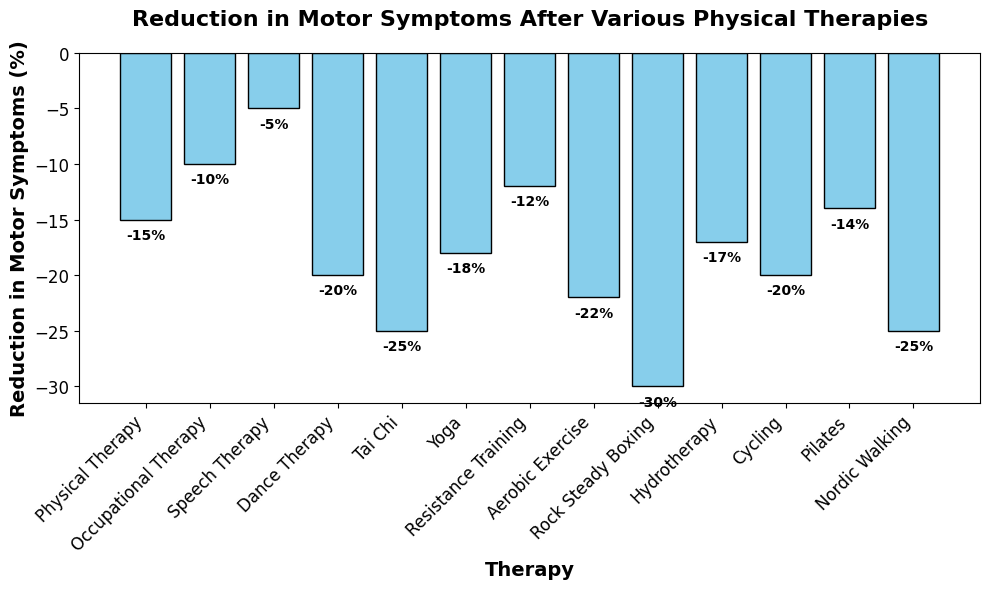Which therapy shows the greatest reduction in motor symptoms? By looking at the heights of the bars, the tallest negative value indicates the greatest reduction. Rock Steady Boxing has the tallest bar, representing the highest reduction of 30%.
Answer: Rock Steady Boxing Which therapies have a reduction of motor symptoms equal to or greater than 20%? Identify bars with heights at -20% or more negative. The therapies that meet this criteria are Dance Therapy, Aerobic Exercise, Cycling, Tai Chi, and Rock Steady Boxing.
Answer: Dance Therapy, Aerobic Exercise, Cycling, Tai Chi, Rock Steady Boxing Is the reduction in motor symptoms for Hydrotherapy greater or less than for Speech Therapy? Compare the bar heights of Hydrotherapy and Speech Therapy. Hydrotherapy has a reduction of -17%, whereas Speech Therapy has -5%. Therefore, Hydrotherapy has a greater reduction.
Answer: Greater What's the average reduction in motor symptoms across all therapies? Add all reductions and divide by the number of therapies. Sum = -15 + -10 + -5 + -20 + -25 + -18 + -12 + -22 + -30 + -17 + -20 + -14 + -25 = -233. Number of therapies = 13. Therefore, average reduction = -233 / 13 ≈ -17.92%.
Answer: -17.92% Which therapy has a reduction in motor symptoms closest to the average reduction? Calculate the difference between each therapy's reduction and the average reduction of -17.92%, then find the smallest difference. Pilates has a reduction of -14%, which is closest to -17.92% with a difference of approximately 3.92%.
Answer: Pilates Which therapy shows the least reduction in motor symptoms? Identify the smallest negative value. Speech Therapy shows a reduction of -5%, which is the least.
Answer: Speech Therapy Is the reduction in motor symptoms for Yoga greater than for Resistance Training? Compare the bar heights of Yoga and Resistance Training. Yoga has a reduction of -18%, whereas Resistance Training has -12%. Therefore, Yoga has a greater reduction.
Answer: Greater What is the total reduction in motor symptoms for Physical Therapy and Tai Chi combined? Add the reductions for Physical Therapy and Tai Chi. Physical Therapy is -15%, and Tai Chi is -25%. Total reduction = -15 + -25 = -40%.
Answer: -40% Are there any therapies with equal reductions in motor symptoms? Compare all therapies’ reductions to find any equal values. There are no therapies with exactly equal reductions in this dataset.
Answer: No 